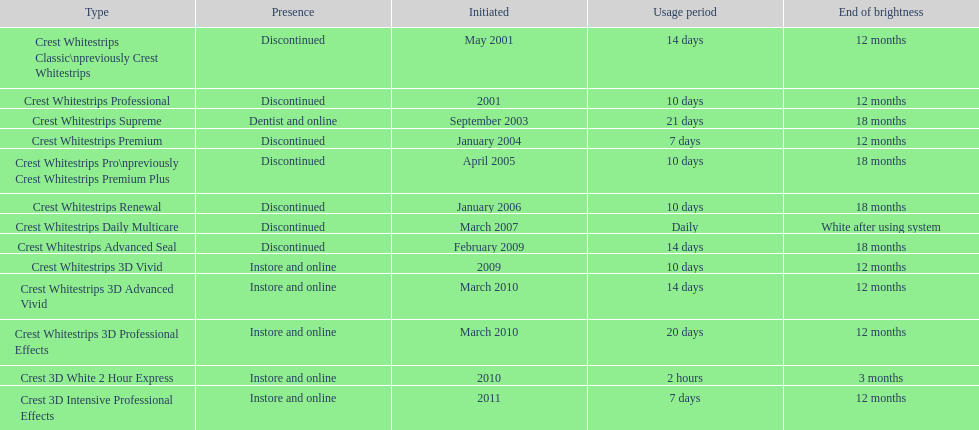What quantity of products made their debut in 2010? 3. 